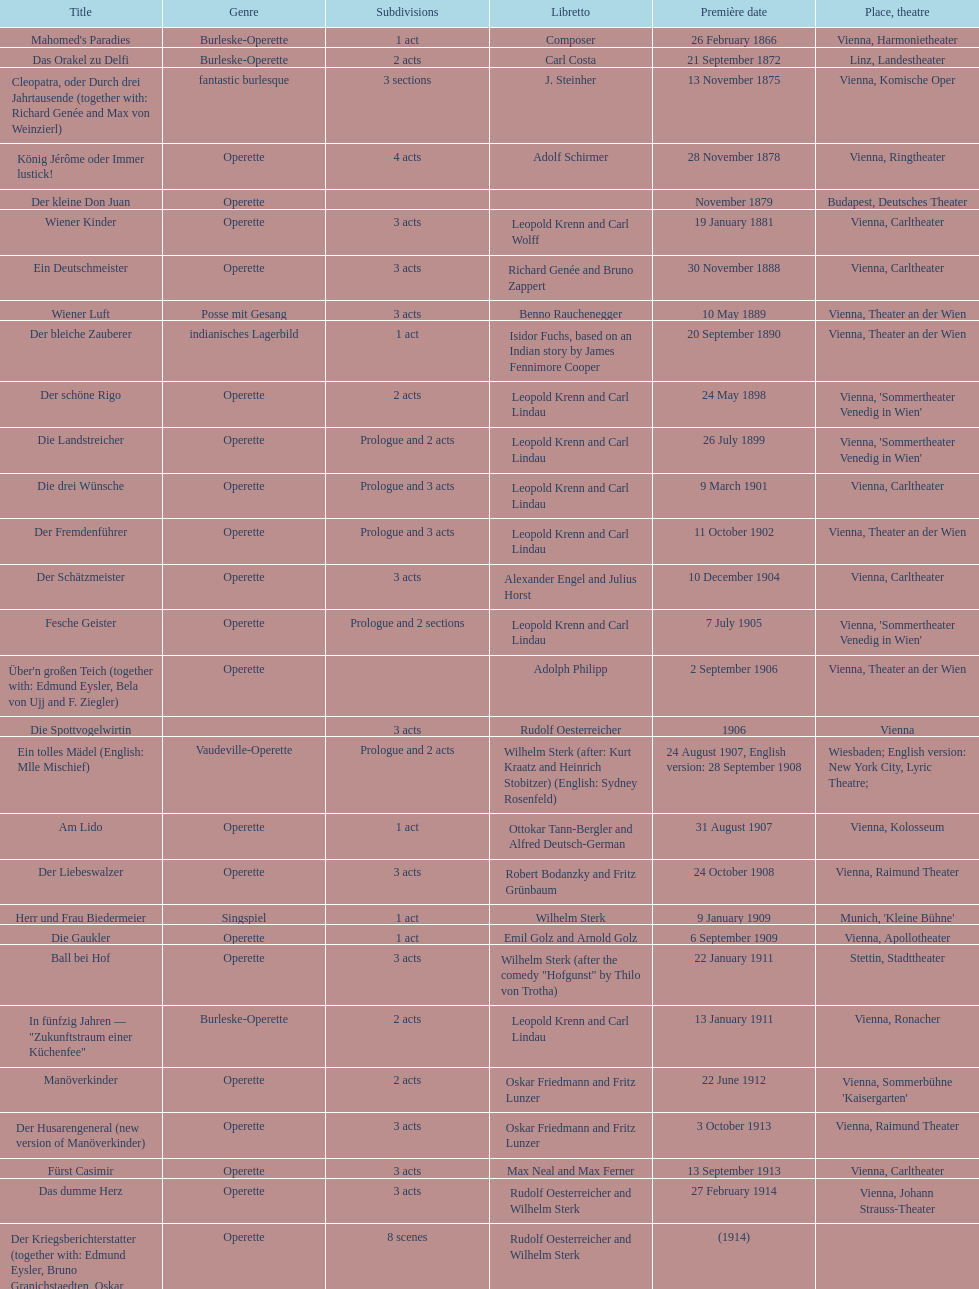In which municipality did the most operettas have their first performance? Vienna. 